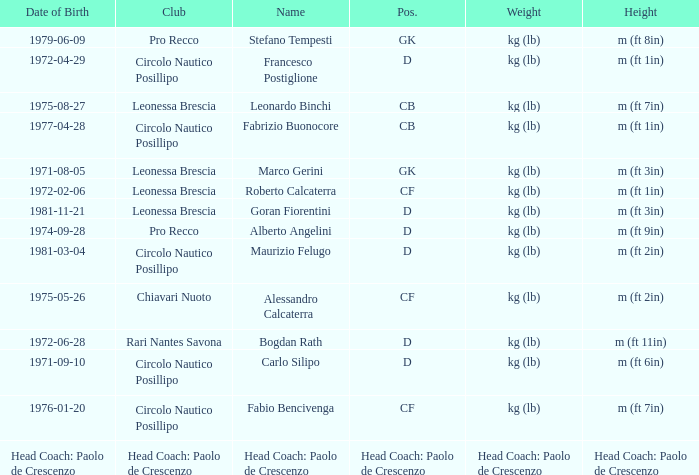What is the weight of the entry that has a date of birth of 1981-11-21? Kg (lb). 